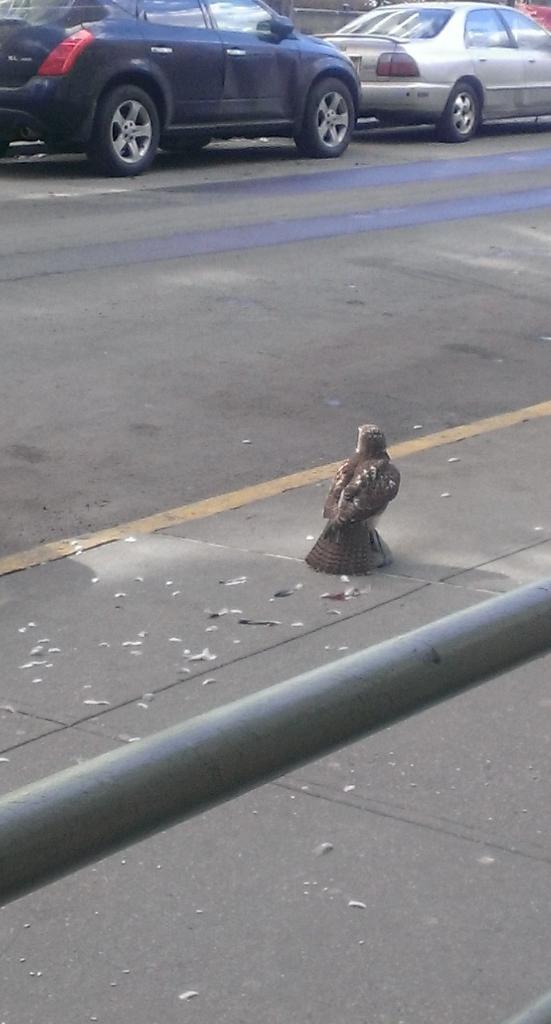What is the main feature of the image? There is a road in the image. What can be seen near the road? Two cars are parked on the side of the road. Are there any animals visible in the image? Yes, there is a bird on a footpath in the image. What other object can be seen in the image? There is an iron rod in the image. What type of stem can be seen growing near the iron rod in the image? There is no stem visible in the image; it only features a road, parked cars, a bird, and an iron rod. 